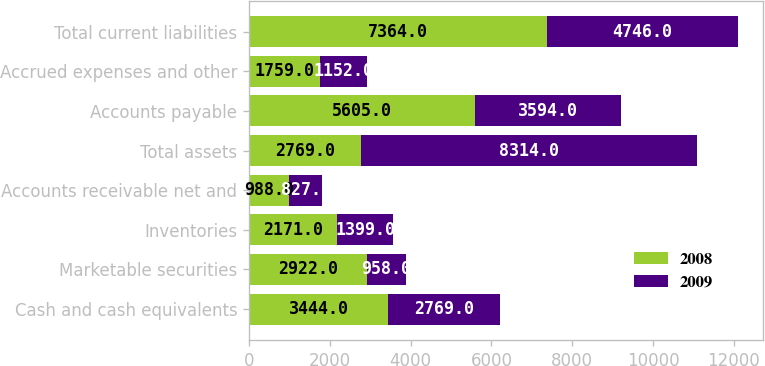Convert chart. <chart><loc_0><loc_0><loc_500><loc_500><stacked_bar_chart><ecel><fcel>Cash and cash equivalents<fcel>Marketable securities<fcel>Inventories<fcel>Accounts receivable net and<fcel>Total assets<fcel>Accounts payable<fcel>Accrued expenses and other<fcel>Total current liabilities<nl><fcel>2008<fcel>3444<fcel>2922<fcel>2171<fcel>988<fcel>2769<fcel>5605<fcel>1759<fcel>7364<nl><fcel>2009<fcel>2769<fcel>958<fcel>1399<fcel>827<fcel>8314<fcel>3594<fcel>1152<fcel>4746<nl></chart> 